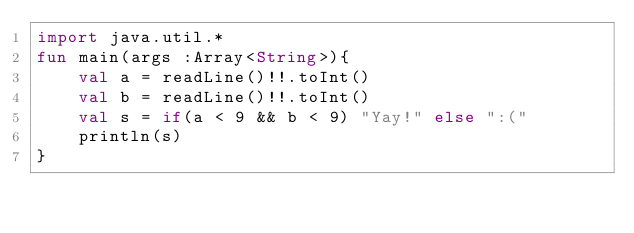Convert code to text. <code><loc_0><loc_0><loc_500><loc_500><_Kotlin_>import java.util.*
fun main(args :Array<String>){
    val a = readLine()!!.toInt()
    val b = readLine()!!.toInt()
    val s = if(a < 9 && b < 9) "Yay!" else ":("
    println(s)
}
</code> 